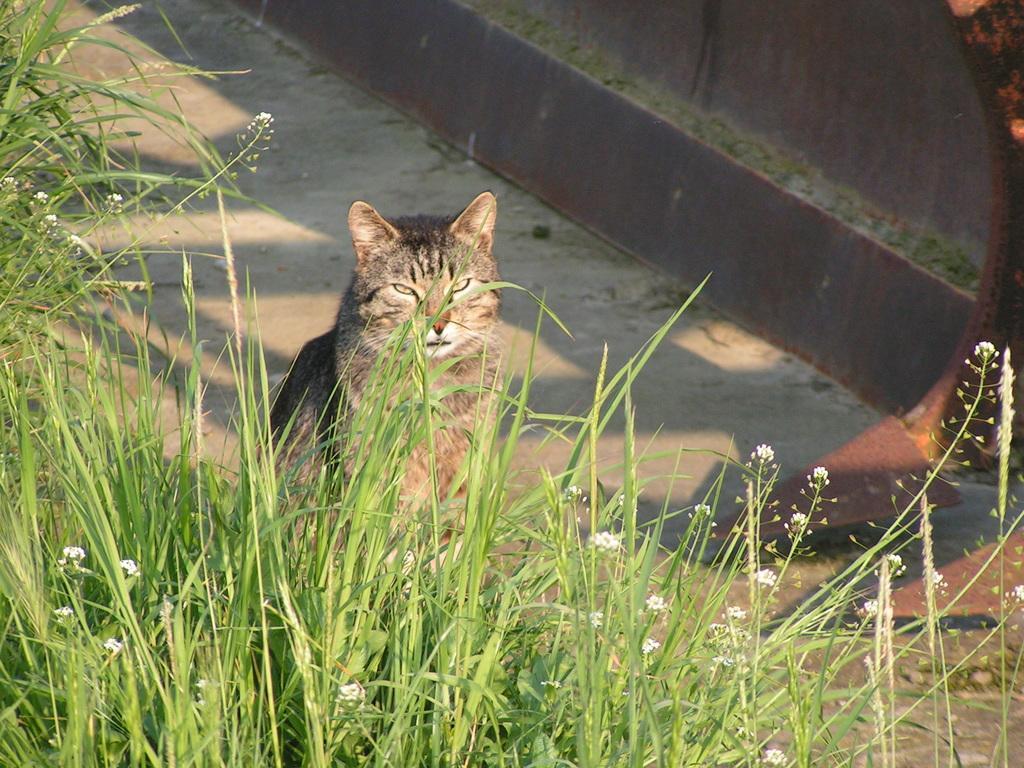How would you summarize this image in a sentence or two? In this image we can see a cat on the ground, there are some plants with flowers on it and also we can see the wall. 